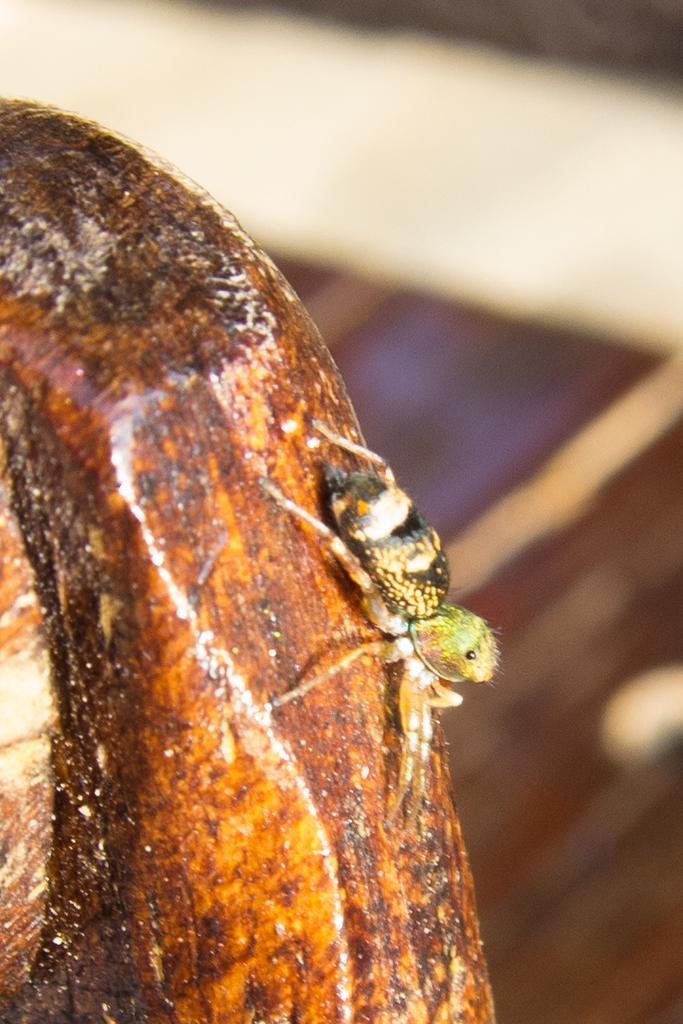Please provide a concise description of this image. In this image there is an insect on a wood, in the background it is blurred. 